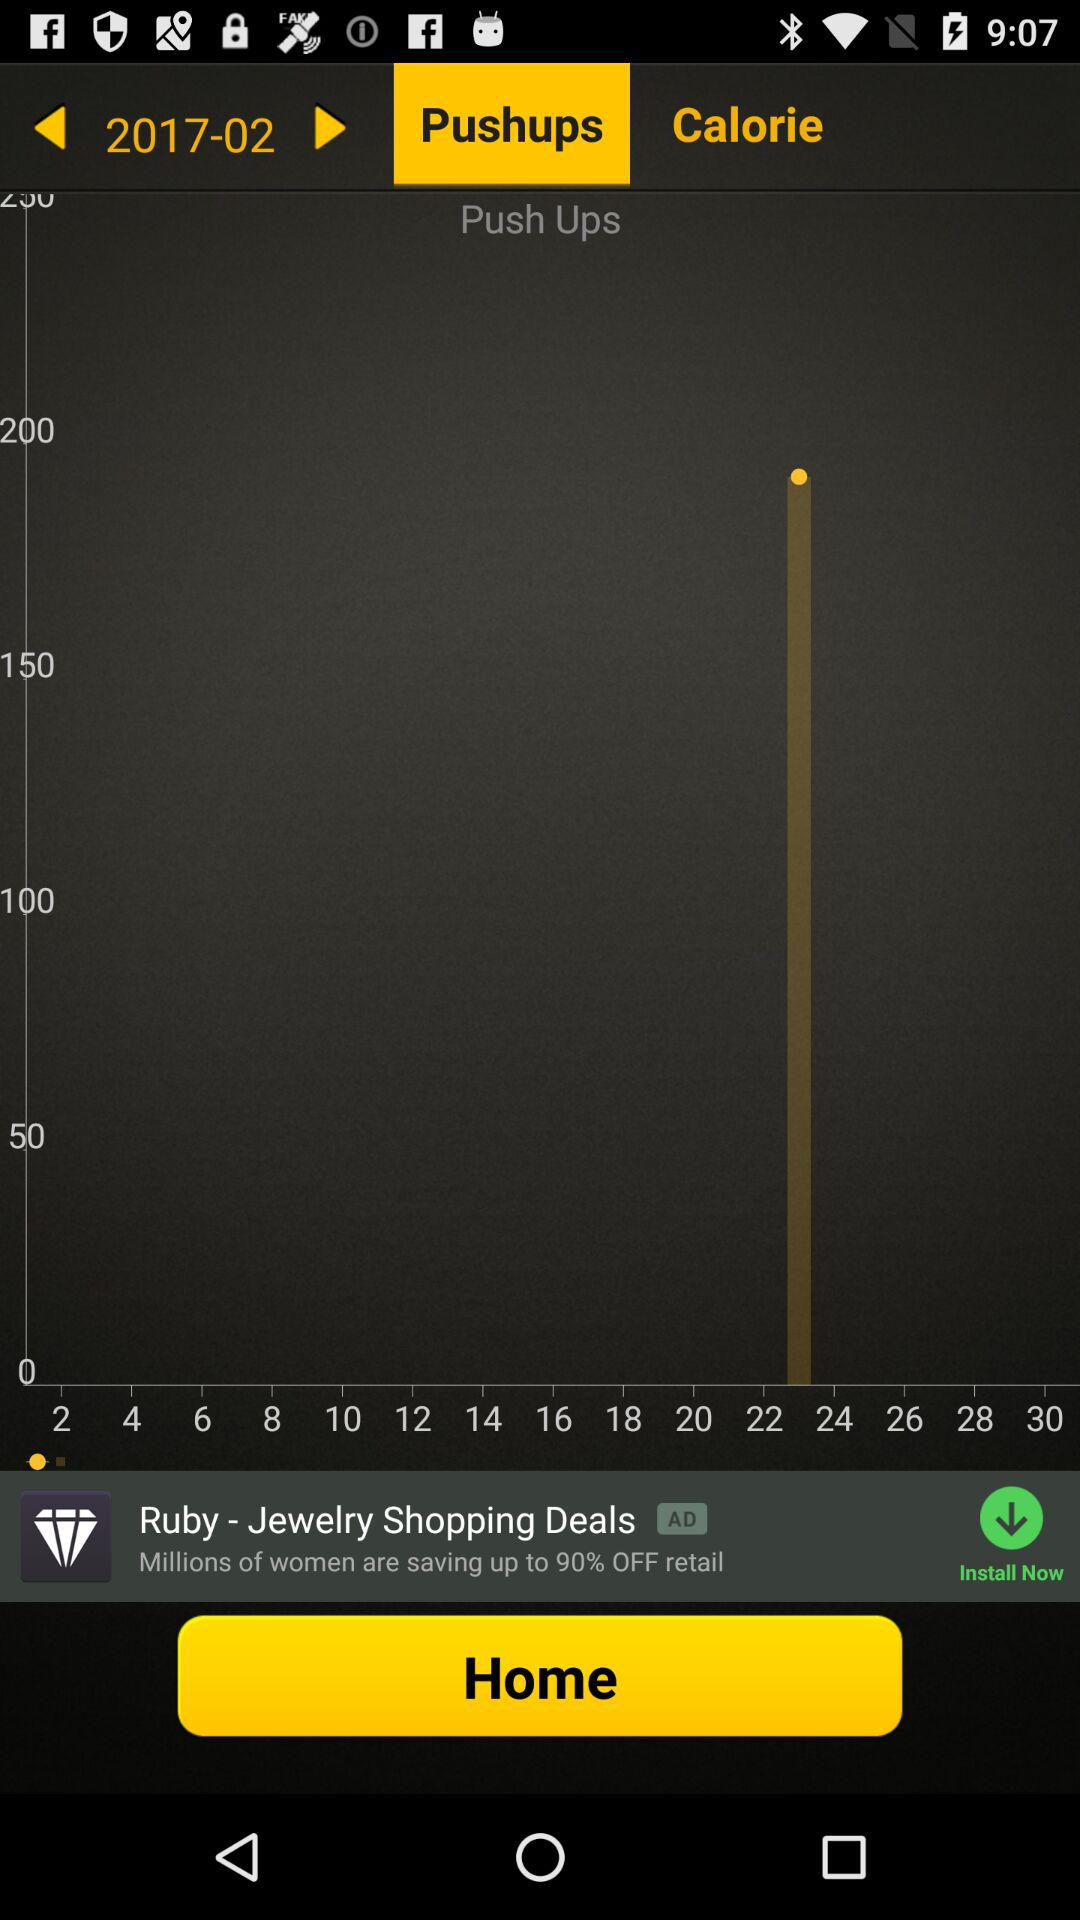Which tab is selected? The selected tab is "Pushups". 